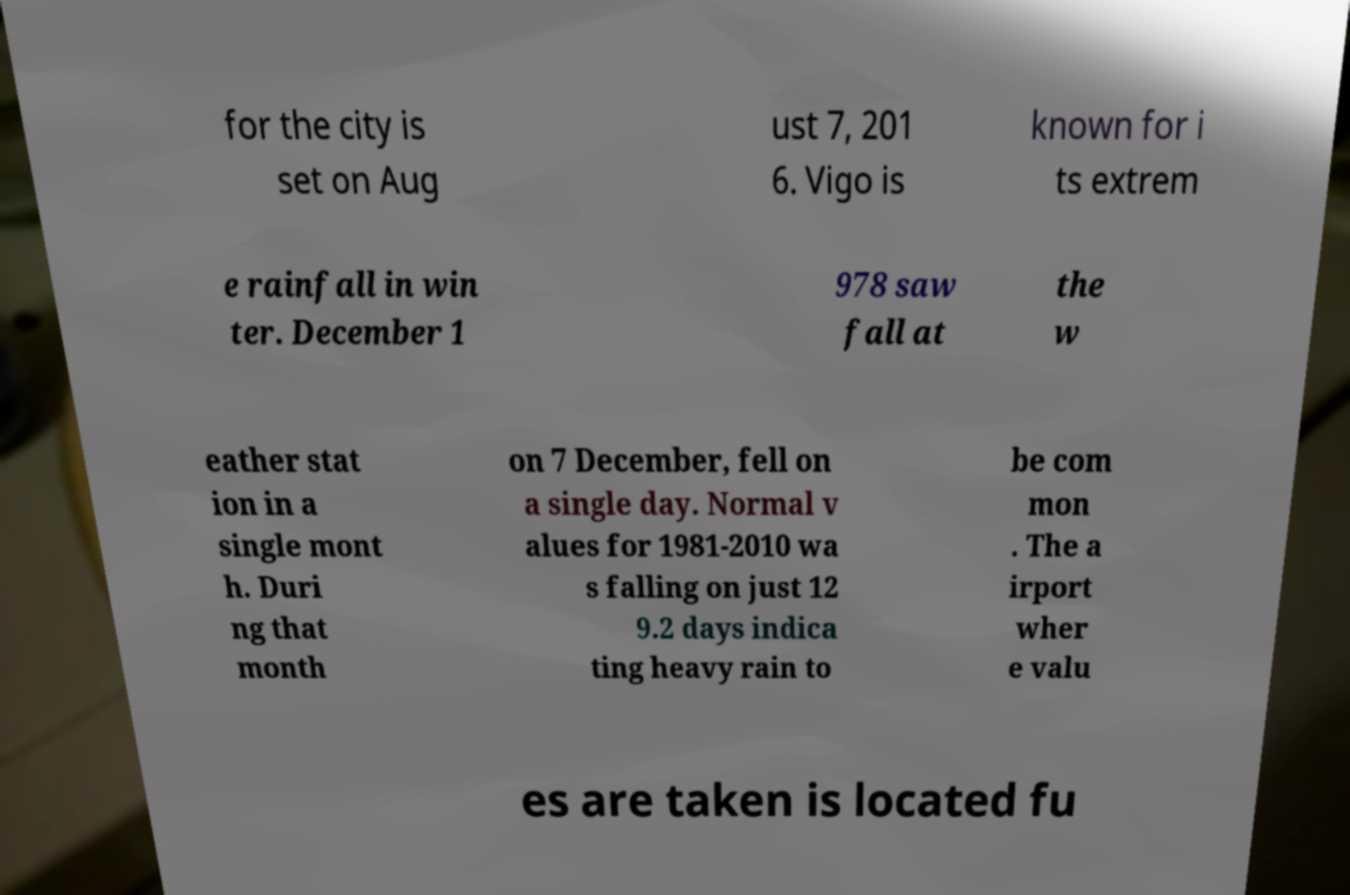Could you extract and type out the text from this image? for the city is set on Aug ust 7, 201 6. Vigo is known for i ts extrem e rainfall in win ter. December 1 978 saw fall at the w eather stat ion in a single mont h. Duri ng that month on 7 December, fell on a single day. Normal v alues for 1981-2010 wa s falling on just 12 9.2 days indica ting heavy rain to be com mon . The a irport wher e valu es are taken is located fu 